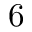Convert formula to latex. <formula><loc_0><loc_0><loc_500><loc_500>6</formula> 